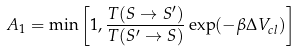Convert formula to latex. <formula><loc_0><loc_0><loc_500><loc_500>A _ { 1 } = \min \left [ 1 , \frac { T ( S \rightarrow S ^ { \prime } ) } { T ( S ^ { \prime } \rightarrow S ) } \exp ( - \beta \Delta V _ { c l } ) \right ]</formula> 